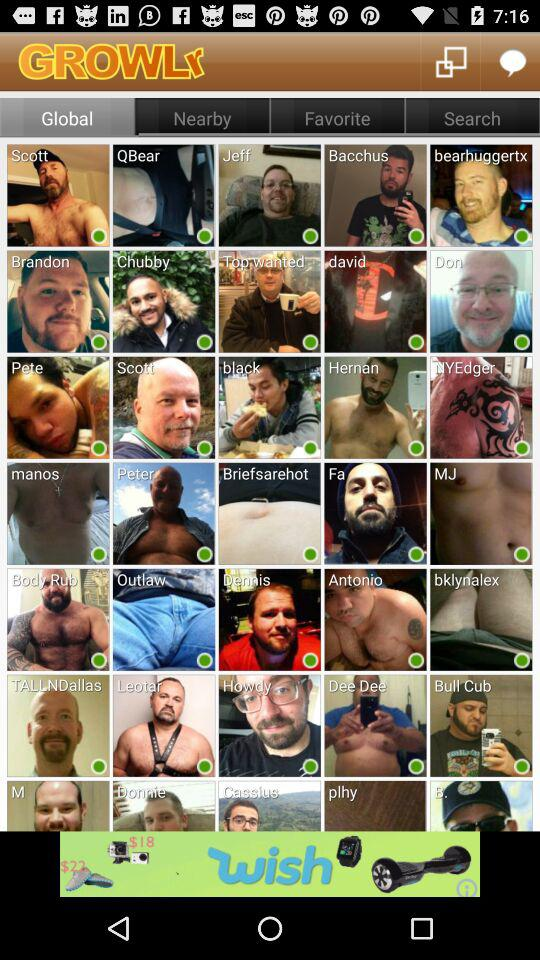How old is "Bacchus"?
When the provided information is insufficient, respond with <no answer>. <no answer> 